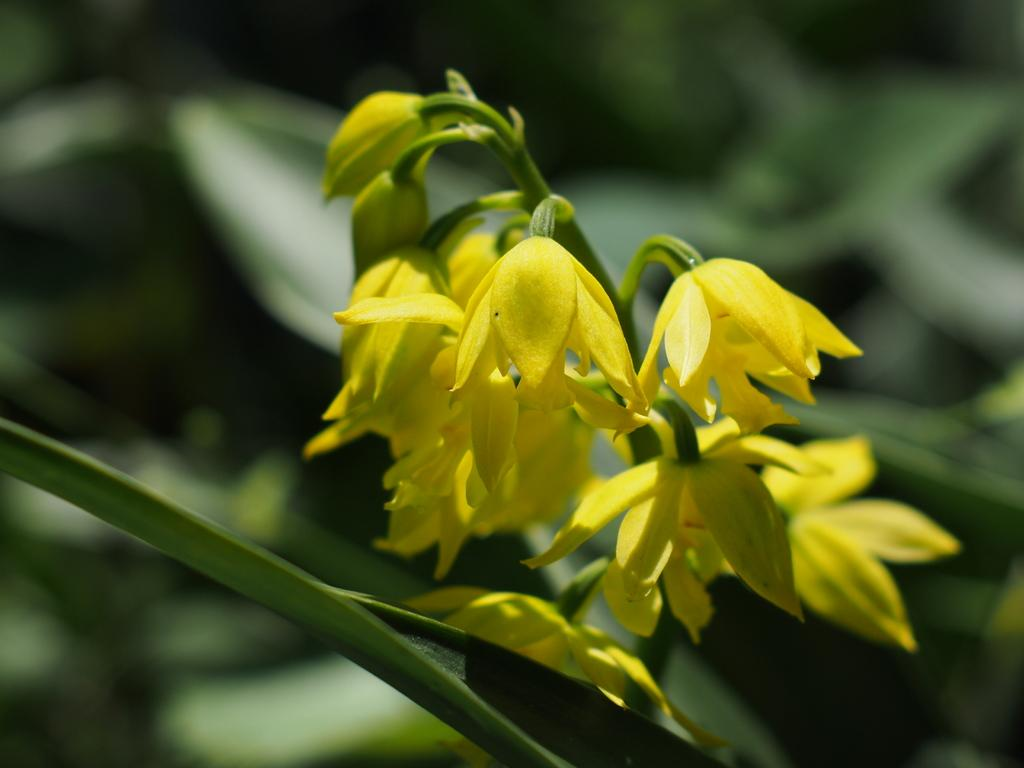What type of plants can be seen in the image? There are flowers in the image. Can you describe the growth stage of the flowers? There are buds on a stem in the image. How would you characterize the background of the image? The background of the image is blurry. What news is being reported by the eye in the image? There is no eye present in the image, and therefore no news being reported. What type of self-reflection can be seen in the image? There is no self-reflection present in the image; it features flowers and buds on a stem. 